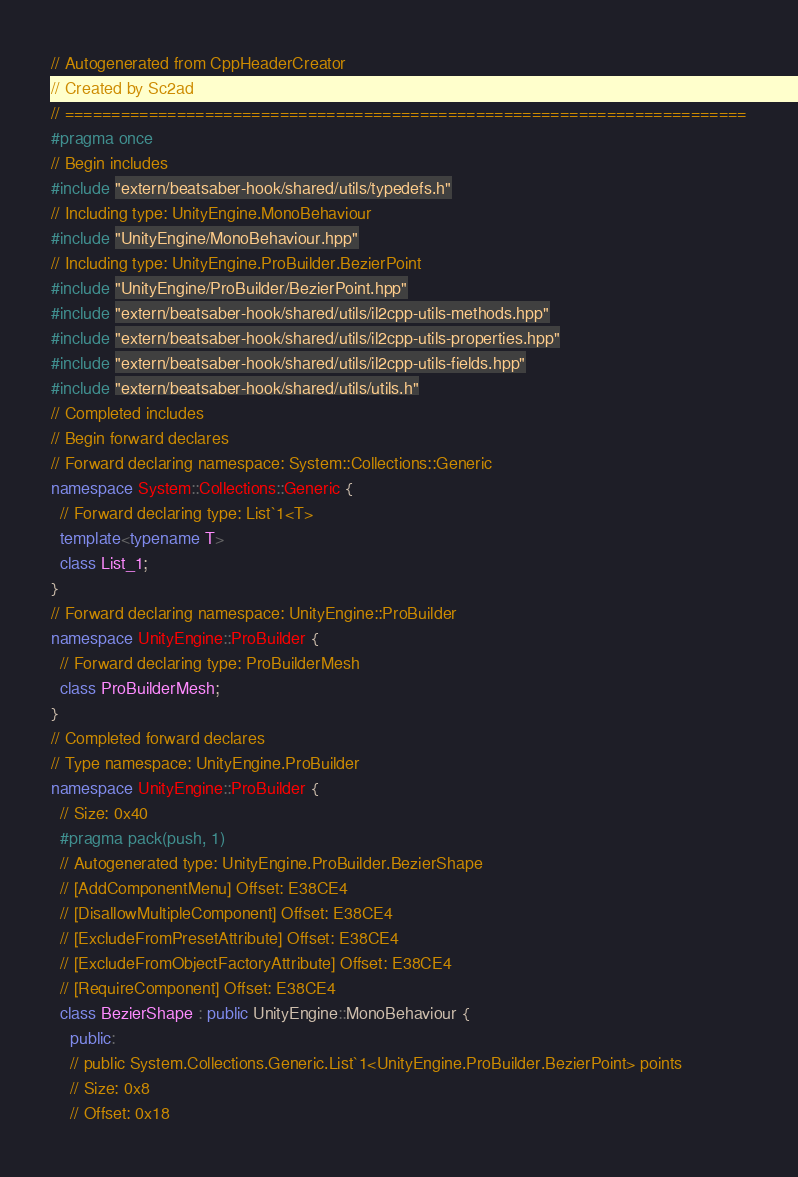Convert code to text. <code><loc_0><loc_0><loc_500><loc_500><_C++_>// Autogenerated from CppHeaderCreator
// Created by Sc2ad
// =========================================================================
#pragma once
// Begin includes
#include "extern/beatsaber-hook/shared/utils/typedefs.h"
// Including type: UnityEngine.MonoBehaviour
#include "UnityEngine/MonoBehaviour.hpp"
// Including type: UnityEngine.ProBuilder.BezierPoint
#include "UnityEngine/ProBuilder/BezierPoint.hpp"
#include "extern/beatsaber-hook/shared/utils/il2cpp-utils-methods.hpp"
#include "extern/beatsaber-hook/shared/utils/il2cpp-utils-properties.hpp"
#include "extern/beatsaber-hook/shared/utils/il2cpp-utils-fields.hpp"
#include "extern/beatsaber-hook/shared/utils/utils.h"
// Completed includes
// Begin forward declares
// Forward declaring namespace: System::Collections::Generic
namespace System::Collections::Generic {
  // Forward declaring type: List`1<T>
  template<typename T>
  class List_1;
}
// Forward declaring namespace: UnityEngine::ProBuilder
namespace UnityEngine::ProBuilder {
  // Forward declaring type: ProBuilderMesh
  class ProBuilderMesh;
}
// Completed forward declares
// Type namespace: UnityEngine.ProBuilder
namespace UnityEngine::ProBuilder {
  // Size: 0x40
  #pragma pack(push, 1)
  // Autogenerated type: UnityEngine.ProBuilder.BezierShape
  // [AddComponentMenu] Offset: E38CE4
  // [DisallowMultipleComponent] Offset: E38CE4
  // [ExcludeFromPresetAttribute] Offset: E38CE4
  // [ExcludeFromObjectFactoryAttribute] Offset: E38CE4
  // [RequireComponent] Offset: E38CE4
  class BezierShape : public UnityEngine::MonoBehaviour {
    public:
    // public System.Collections.Generic.List`1<UnityEngine.ProBuilder.BezierPoint> points
    // Size: 0x8
    // Offset: 0x18</code> 